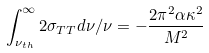Convert formula to latex. <formula><loc_0><loc_0><loc_500><loc_500>\int _ { \nu _ { t h } } ^ { \infty } 2 \sigma _ { T T } d \nu / \nu = - { \frac { 2 \pi ^ { 2 } \alpha \kappa ^ { 2 } } { M ^ { 2 } } }</formula> 